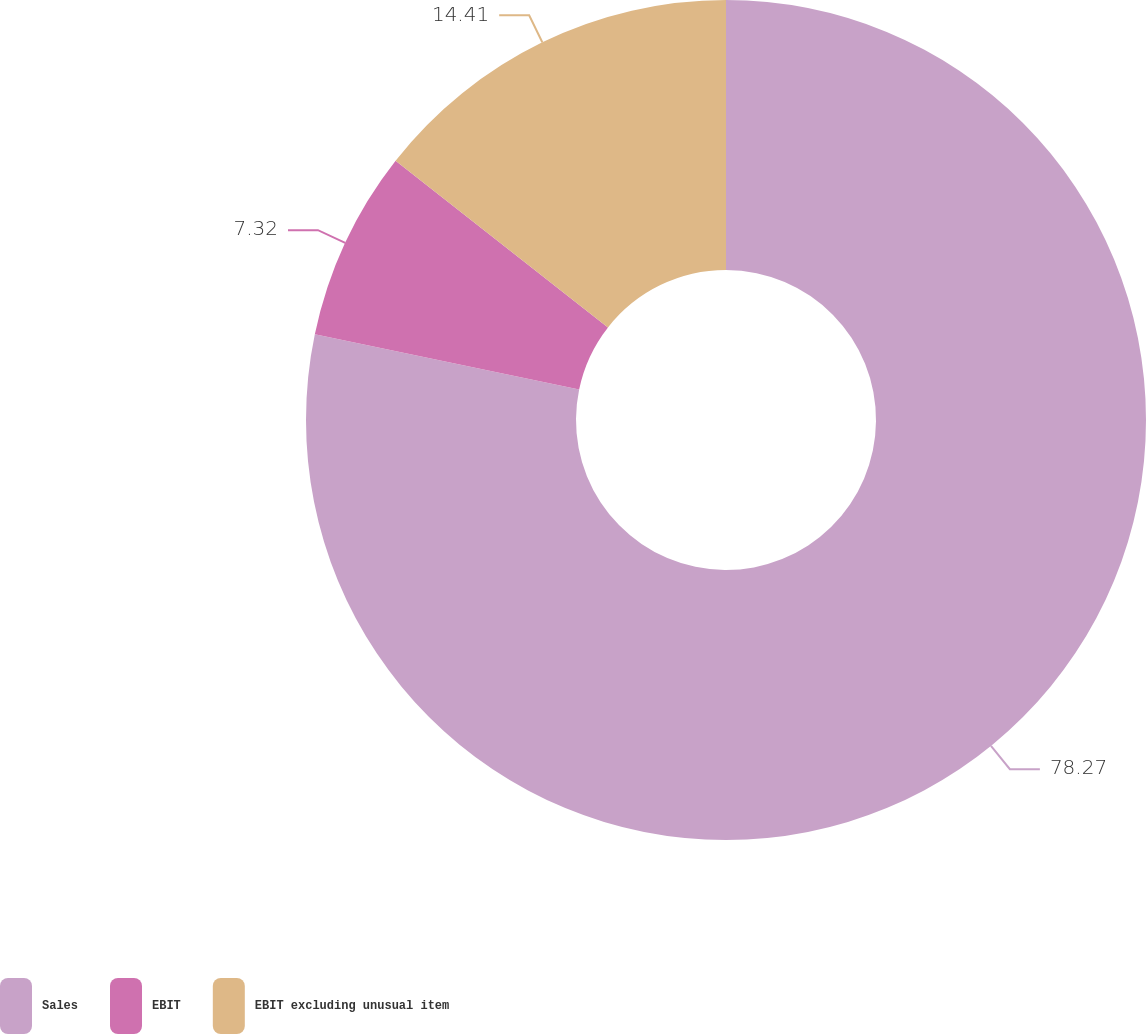Convert chart. <chart><loc_0><loc_0><loc_500><loc_500><pie_chart><fcel>Sales<fcel>EBIT<fcel>EBIT excluding unusual item<nl><fcel>78.27%<fcel>7.32%<fcel>14.41%<nl></chart> 